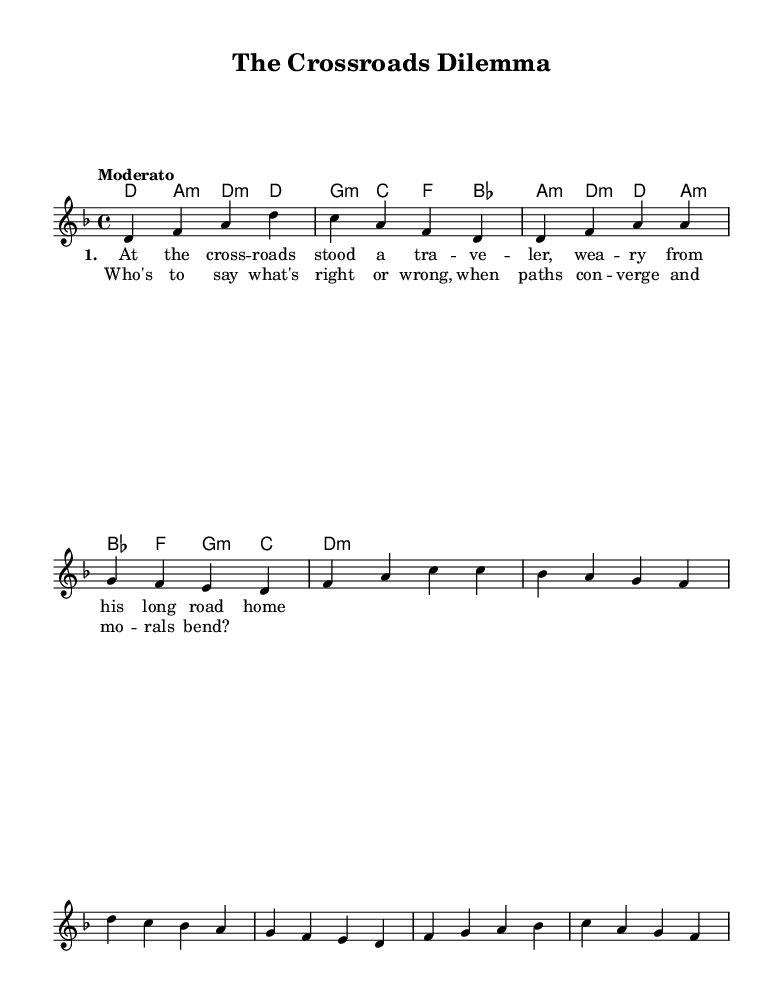What is the key signature of this music? The key signature shows two flat symbols, indicating that the music is in D minor, which is the relative minor of F major and includes B flat and E flat.
Answer: D minor What is the time signature of this piece? The time signature is indicated as 4/4, which means there are four beats in each measure, and the quarter note receives one beat.
Answer: 4/4 What is the tempo marking for this piece? The tempo is marked as "Moderato," which indicates a moderate speed, typically interpreted as between 108 to 120 beats per minute.
Answer: Moderato How many measures are in the chorus? The chorus section has four measures, as counted by the repeated phrasing and indicating a full musical thought that comprises the section.
Answer: Four Which chord is played during the first measure of the introduction? The first measure of the introduction is marked with the chord D minor, which is indicated as d:m1 in the harmonies section.
Answer: D minor What theme is suggested by the lyrics and title? The title "The Crossroads Dilemma" and the lyrics reference a traveler facing critical decisions, suggesting themes of choice and morality.
Answer: Choices and morality 